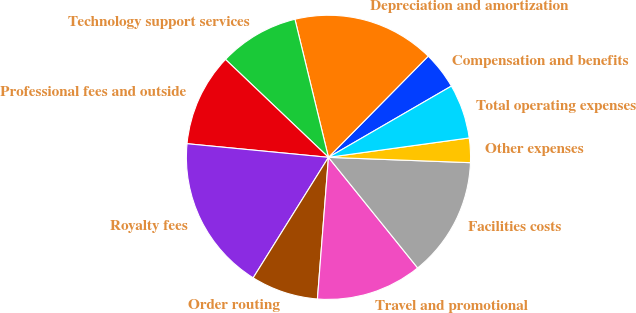Convert chart. <chart><loc_0><loc_0><loc_500><loc_500><pie_chart><fcel>Compensation and benefits<fcel>Depreciation and amortization<fcel>Technology support services<fcel>Professional fees and outside<fcel>Royalty fees<fcel>Order routing<fcel>Travel and promotional<fcel>Facilities costs<fcel>Other expenses<fcel>Total operating expenses<nl><fcel>4.25%<fcel>16.18%<fcel>9.11%<fcel>10.57%<fcel>17.64%<fcel>7.65%<fcel>12.04%<fcel>13.6%<fcel>2.78%<fcel>6.18%<nl></chart> 